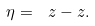Convert formula to latex. <formula><loc_0><loc_0><loc_500><loc_500>\eta = \ z - z .</formula> 